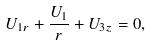<formula> <loc_0><loc_0><loc_500><loc_500>U _ { 1 r } + \frac { U _ { 1 } } { r } + U _ { 3 z } = 0 ,</formula> 